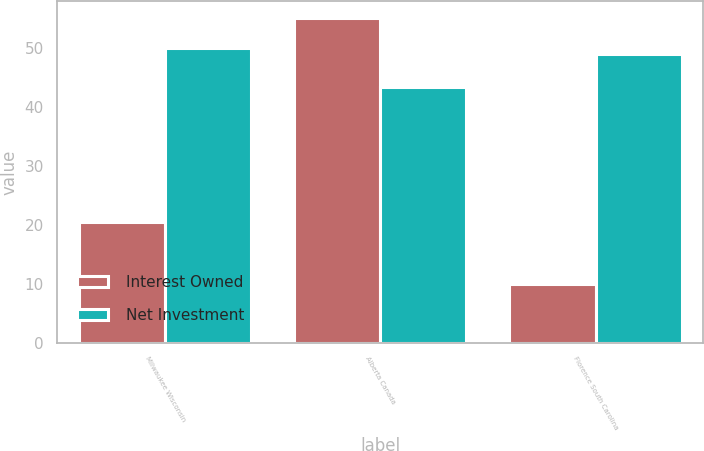Convert chart. <chart><loc_0><loc_0><loc_500><loc_500><stacked_bar_chart><ecel><fcel>Milwaukee Wisconsin<fcel>Alberta Canada<fcel>Florence South Carolina<nl><fcel>Interest Owned<fcel>20.5<fcel>55.2<fcel>10<nl><fcel>Net Investment<fcel>50<fcel>43.37<fcel>49<nl></chart> 